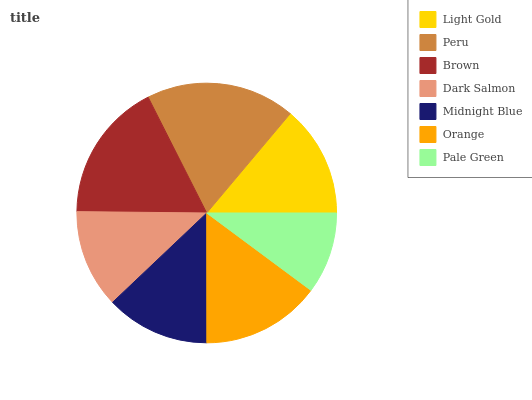Is Pale Green the minimum?
Answer yes or no. Yes. Is Peru the maximum?
Answer yes or no. Yes. Is Brown the minimum?
Answer yes or no. No. Is Brown the maximum?
Answer yes or no. No. Is Peru greater than Brown?
Answer yes or no. Yes. Is Brown less than Peru?
Answer yes or no. Yes. Is Brown greater than Peru?
Answer yes or no. No. Is Peru less than Brown?
Answer yes or no. No. Is Light Gold the high median?
Answer yes or no. Yes. Is Light Gold the low median?
Answer yes or no. Yes. Is Peru the high median?
Answer yes or no. No. Is Peru the low median?
Answer yes or no. No. 